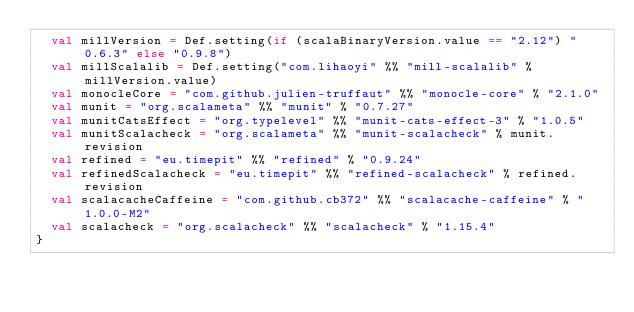Convert code to text. <code><loc_0><loc_0><loc_500><loc_500><_Scala_>  val millVersion = Def.setting(if (scalaBinaryVersion.value == "2.12") "0.6.3" else "0.9.8")
  val millScalalib = Def.setting("com.lihaoyi" %% "mill-scalalib" % millVersion.value)
  val monocleCore = "com.github.julien-truffaut" %% "monocle-core" % "2.1.0"
  val munit = "org.scalameta" %% "munit" % "0.7.27"
  val munitCatsEffect = "org.typelevel" %% "munit-cats-effect-3" % "1.0.5"
  val munitScalacheck = "org.scalameta" %% "munit-scalacheck" % munit.revision
  val refined = "eu.timepit" %% "refined" % "0.9.24"
  val refinedScalacheck = "eu.timepit" %% "refined-scalacheck" % refined.revision
  val scalacacheCaffeine = "com.github.cb372" %% "scalacache-caffeine" % "1.0.0-M2"
  val scalacheck = "org.scalacheck" %% "scalacheck" % "1.15.4"
}
</code> 